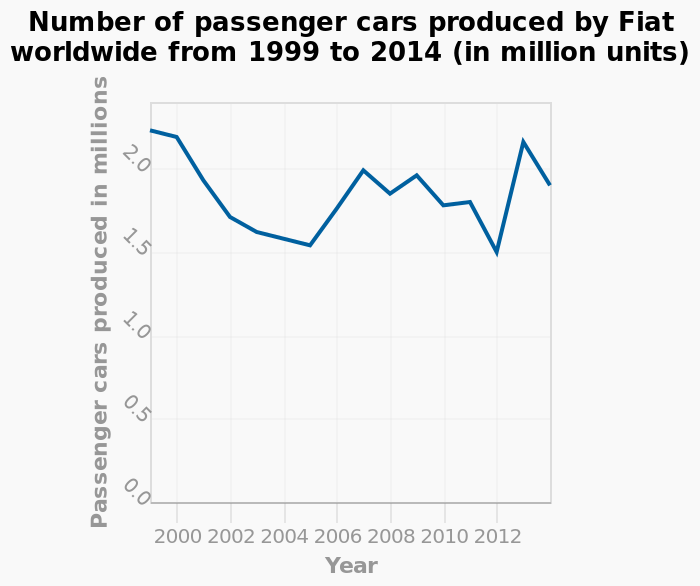<image>
What is the maximum number of passenger cars produced by Fiat worldwide in a single year? The maximum number of passenger cars produced by Fiat worldwide in a single year is 2.0 million units. 